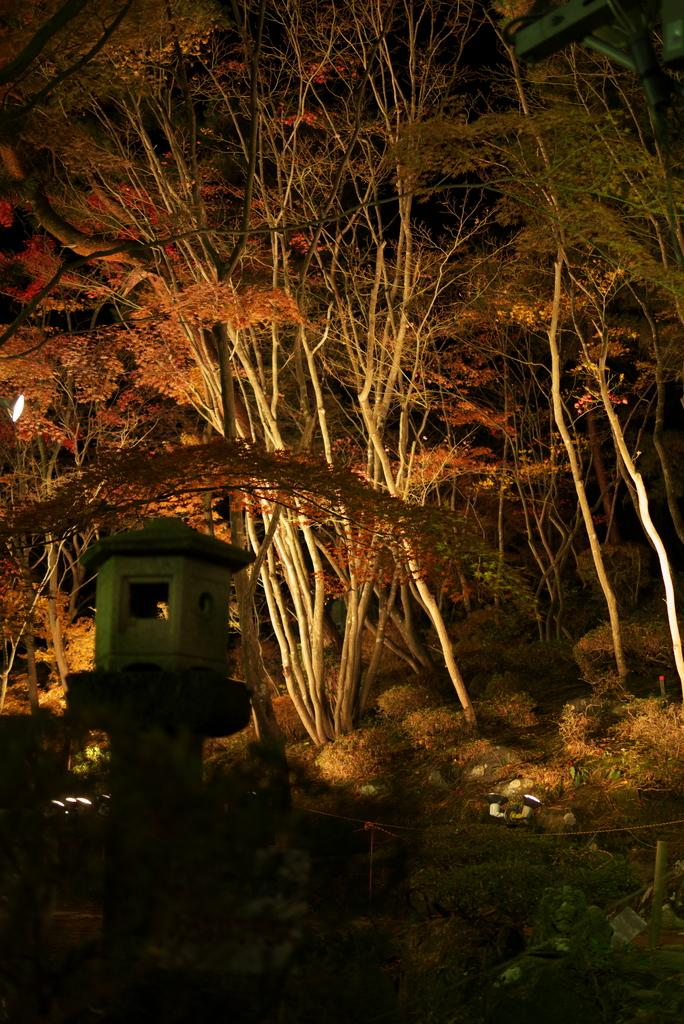What type of vegetation can be seen in the image? There are plants and trees in the image. Where are the plants and trees located? The plants and trees are on land in the image. Can you describe any other objects in the image? There is a light on the left side of the image. How would you describe the overall appearance of the image? The background of the image is dark. What type of belief is represented by the rose in the image? There is no rose present in the image, so it is not possible to determine what belief might be represented. 